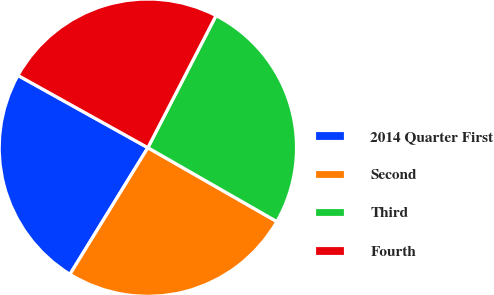Convert chart to OTSL. <chart><loc_0><loc_0><loc_500><loc_500><pie_chart><fcel>2014 Quarter First<fcel>Second<fcel>Third<fcel>Fourth<nl><fcel>24.3%<fcel>25.5%<fcel>25.7%<fcel>24.5%<nl></chart> 